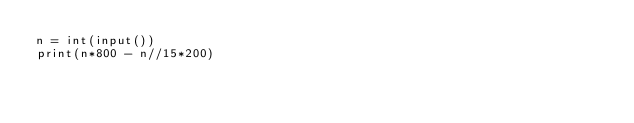<code> <loc_0><loc_0><loc_500><loc_500><_Python_>n = int(input())
print(n*800 - n//15*200)
</code> 